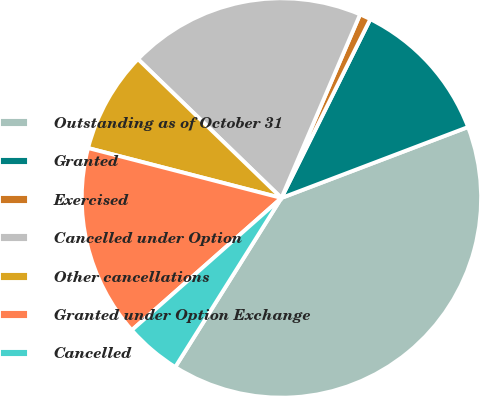Convert chart to OTSL. <chart><loc_0><loc_0><loc_500><loc_500><pie_chart><fcel>Outstanding as of October 31<fcel>Granted<fcel>Exercised<fcel>Cancelled under Option<fcel>Other cancellations<fcel>Granted under Option Exchange<fcel>Cancelled<nl><fcel>39.71%<fcel>11.88%<fcel>0.9%<fcel>19.2%<fcel>8.22%<fcel>15.54%<fcel>4.56%<nl></chart> 